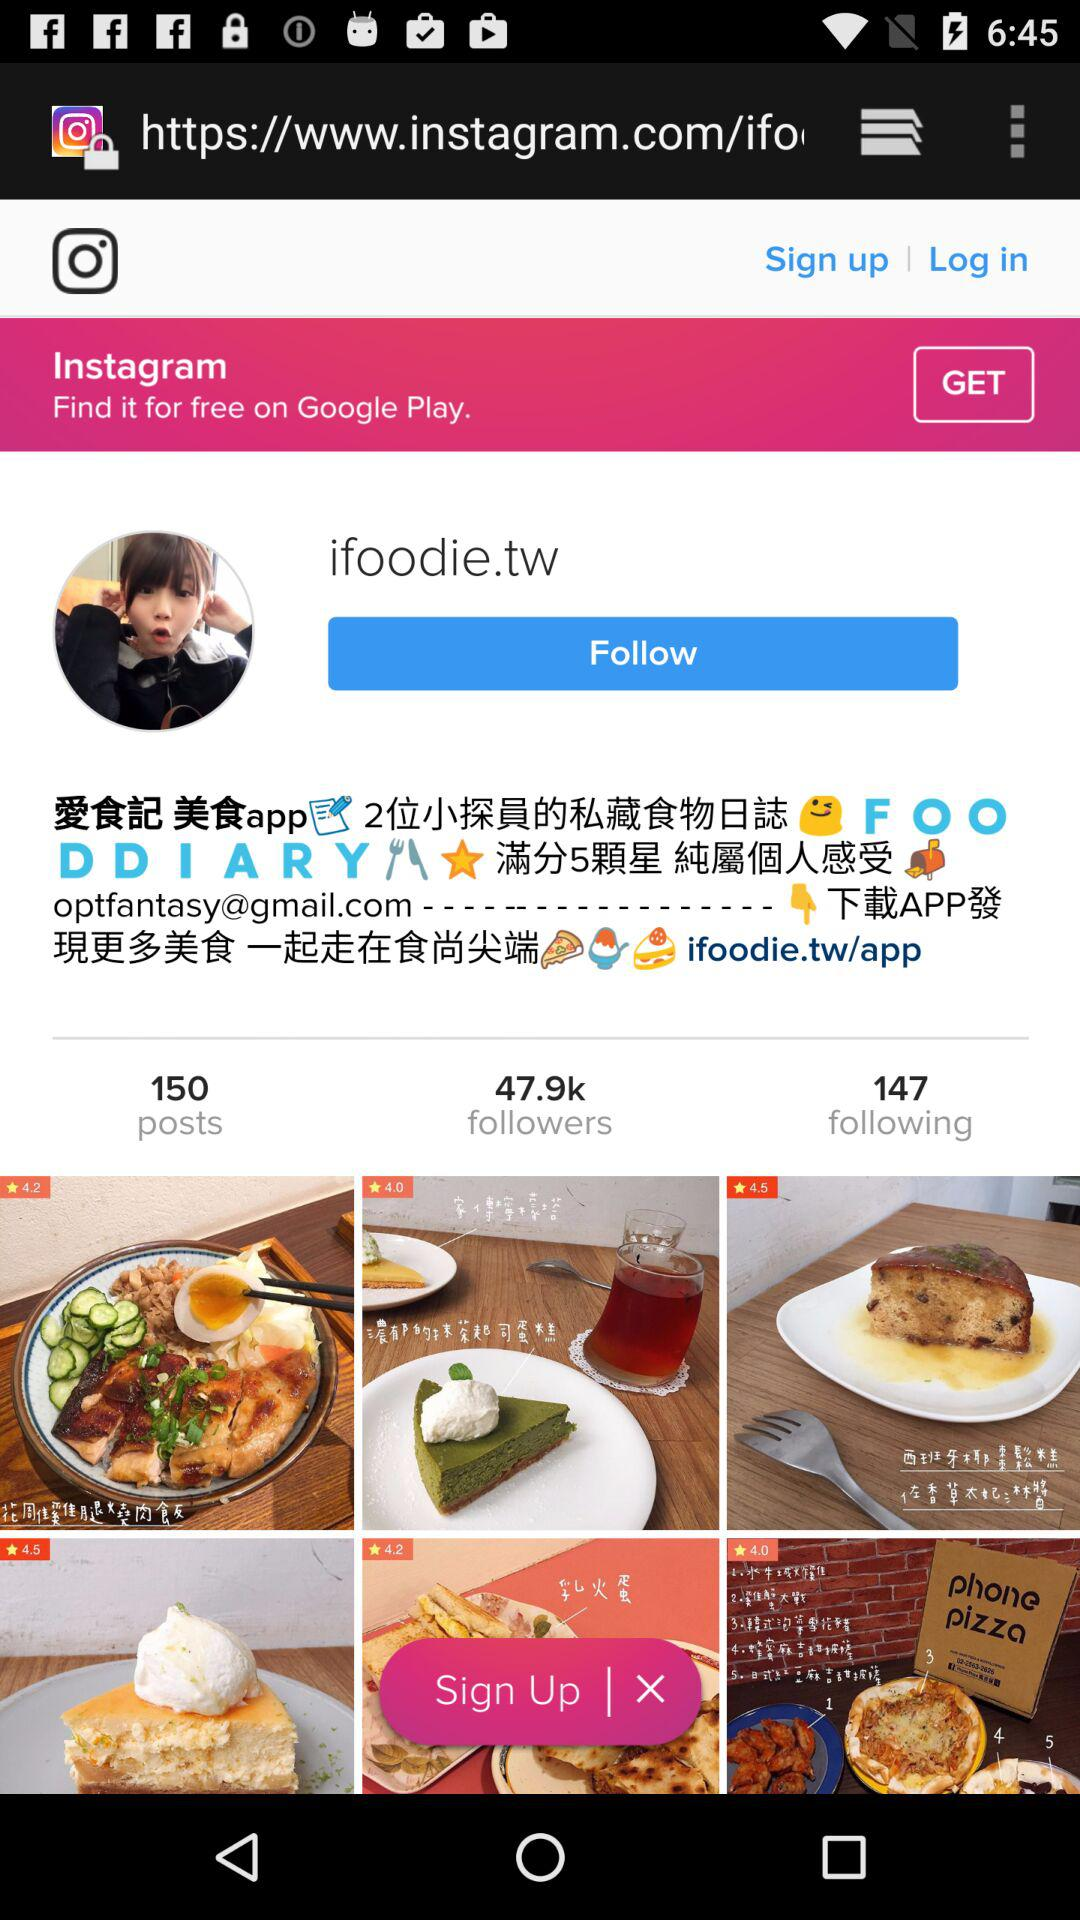How many followers does the account have?
Answer the question using a single word or phrase. 47.9k 